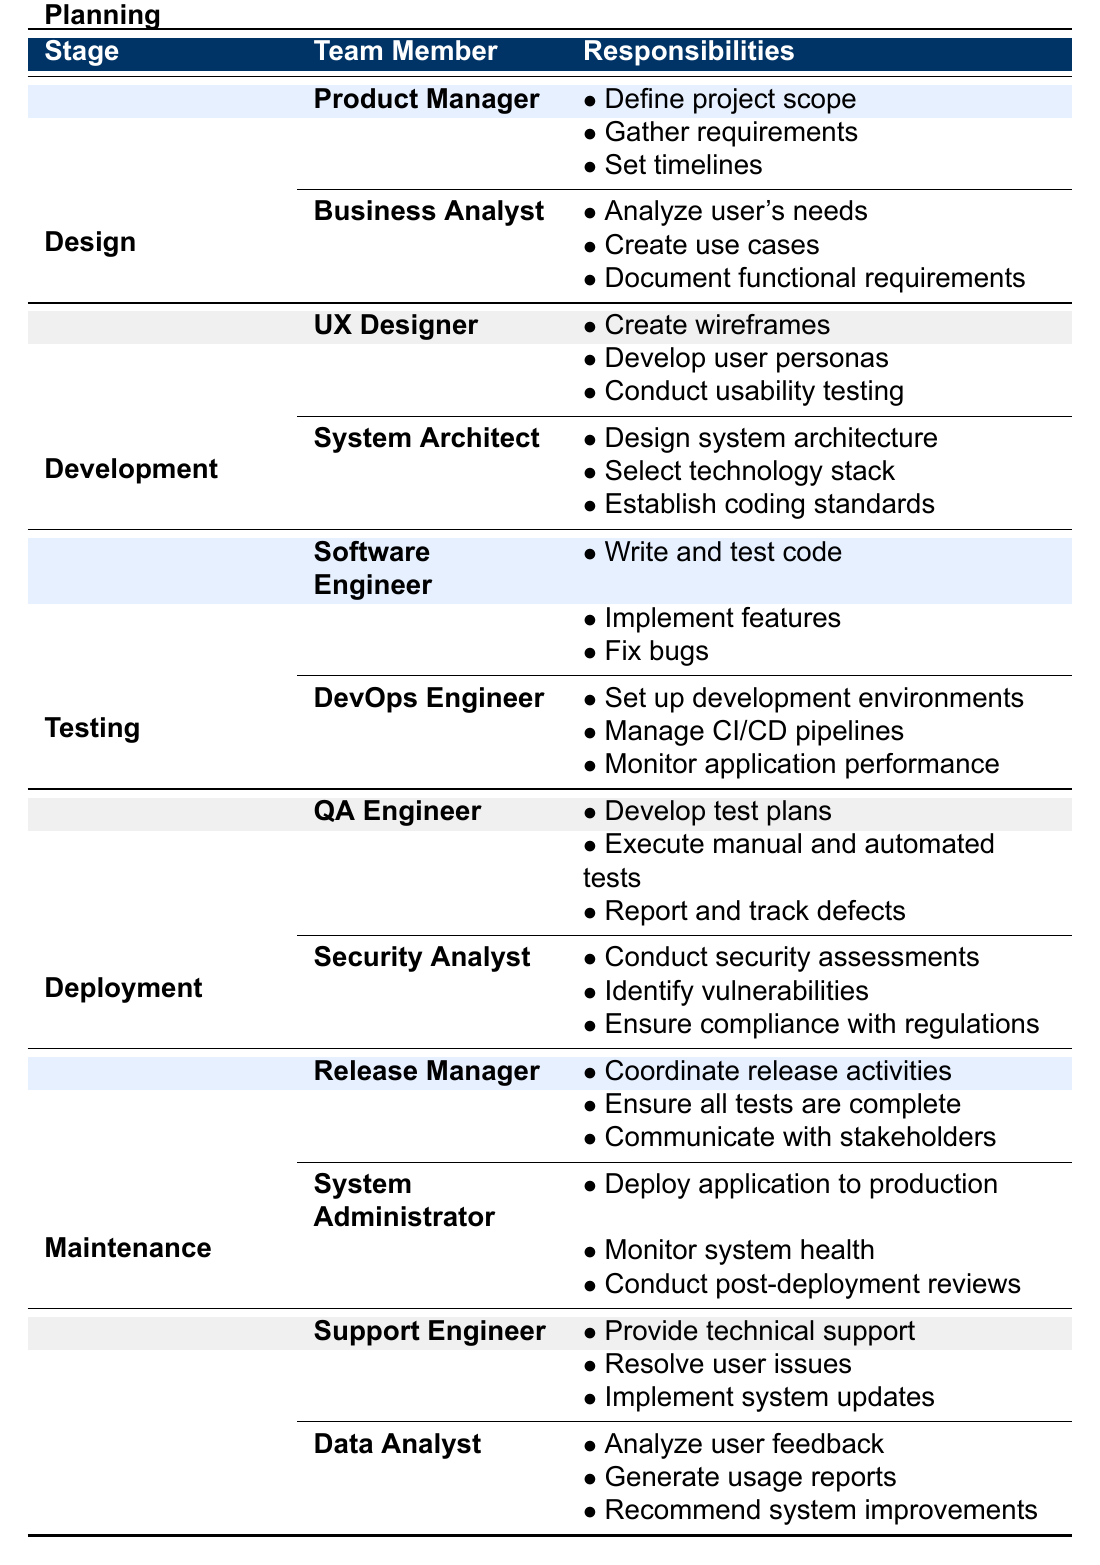What are the responsibilities of the Product Manager? The responsibilities of the Product Manager are listed under the Planning stage. They include defining project scope, gathering requirements, and setting timelines.
Answer: Define project scope, gather requirements, set timelines Which team member is responsible for conducting usability testing? Usability testing is listed under the responsibilities of the UX Designer, who is part of the Design stage.
Answer: UX Designer How many responsibilities does the QA Engineer have? The QA Engineer has three listed responsibilities. They are to develop test plans, execute manual and automated tests, and report and track defects.
Answer: 3 Is the Security Analyst responsible for analyzing user needs? The responsibilities of the Security Analyst are to conduct security assessments, identify vulnerabilities, and ensure compliance with regulations, which does not include analyzing user needs. This responsibility belongs to the Business Analyst.
Answer: No What is the sum of the responsibilities of the Support Engineer and Data Analyst? The Support Engineer has three responsibilities: providing technical support, resolving user issues, and implementing system updates. The Data Analyst also has three responsibilities: analyzing user feedback, generating usage reports, and recommending system improvements. Therefore, the total is 3 + 3 = 6.
Answer: 6 Who is responsible for deploying the application to production? The System Administrator is listed under the Deployment stage with the responsibility to deploy the application to production.
Answer: System Administrator What are the responsibilities of the DevOps Engineer in the Development stage? The responsibilities of the DevOps Engineer are to set up development environments, manage CI/CD pipelines, and monitor application performance, all of which are listed under the Development stage.
Answer: Set up development environments, manage CI/CD pipelines, monitor application performance Which stage has the responsibility to analyze user feedback? The responsibility to analyze user feedback is under the Maintenance stage, specifically assigned to the Data Analyst.
Answer: Maintenance Are there more responsibilities for the Release Manager than for the System Administrator? The Release Manager has three responsibilities: coordinating release activities, ensuring all tests are complete, and communicating with stakeholders. The System Administrator has also three responsibilities. Thus, both roles have the same number of responsibilities.
Answer: No 